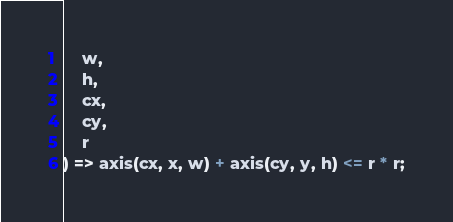<code> <loc_0><loc_0><loc_500><loc_500><_TypeScript_>    w,
    h,
    cx,
    cy,
    r
) => axis(cx, x, w) + axis(cy, y, h) <= r * r;
</code> 